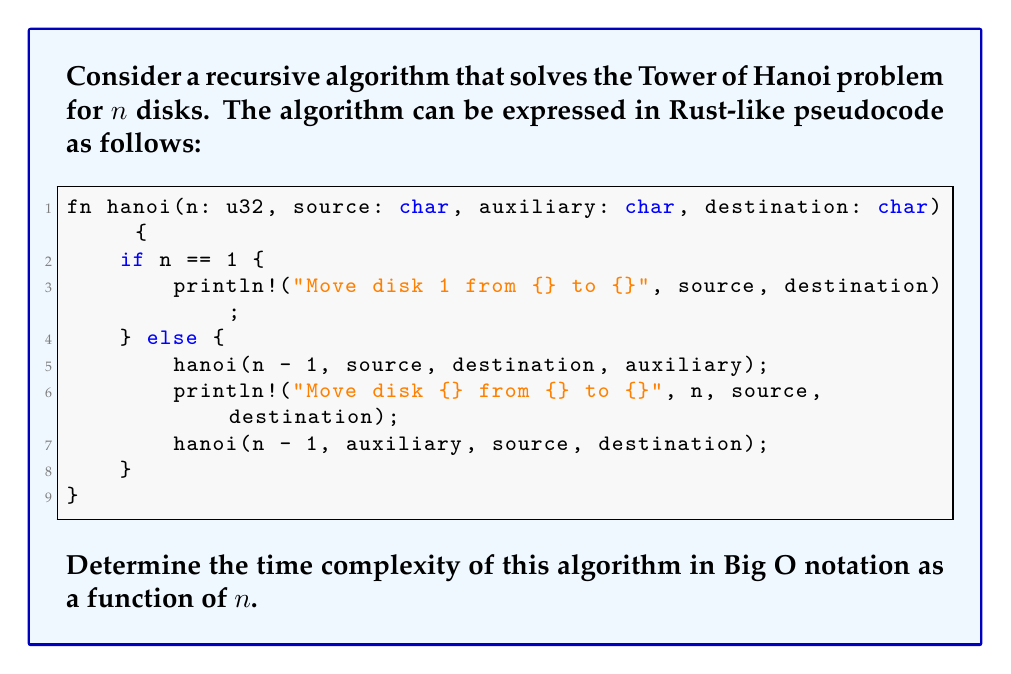Help me with this question. To determine the time complexity of the Tower of Hanoi algorithm, let's analyze it step by step:

1) Let $T(n)$ be the number of steps (moves) required to solve the problem for $n$ disks.

2) Base case: When $n = 1$, the algorithm performs one step (moving the single disk). So, $T(1) = 1$.

3) Recursive case: For $n > 1$, the algorithm:
   a) Solves the problem for $n-1$ disks (moving them to the auxiliary peg)
   b) Moves the largest disk
   c) Solves the problem for $n-1$ disks again (moving them from the auxiliary peg to the destination)

   This can be expressed as: $T(n) = T(n-1) + 1 + T(n-1) = 2T(n-1) + 1$

4) We can expand this recurrence relation:
   $T(n) = 2T(n-1) + 1$
   $    = 2(2T(n-2) + 1) + 1 = 2^2T(n-2) + 2 + 1$
   $    = 2^2(2T(n-3) + 1) + 2 + 1 = 2^3T(n-3) + 2^2 + 2 + 1$
   $    = ...$
   $    = 2^{n-1}T(1) + 2^{n-2} + 2^{n-3} + ... + 2^1 + 2^0$

5) Substituting $T(1) = 1$ and summing the geometric series:
   $T(n) = 2^{n-1} + (2^{n-1} - 1) = 2^n - 1$

6) In Big O notation, we ignore constants and lower-order terms. Therefore, the time complexity is $O(2^n)$.

This exponential time complexity aligns with the fact that the optimal solution to the Tower of Hanoi problem requires $2^n - 1$ moves.
Answer: $O(2^n)$ 